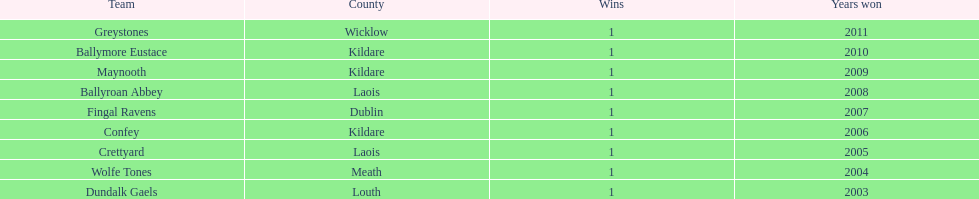What is the cumulative number of wins shown on the chart? 9. 